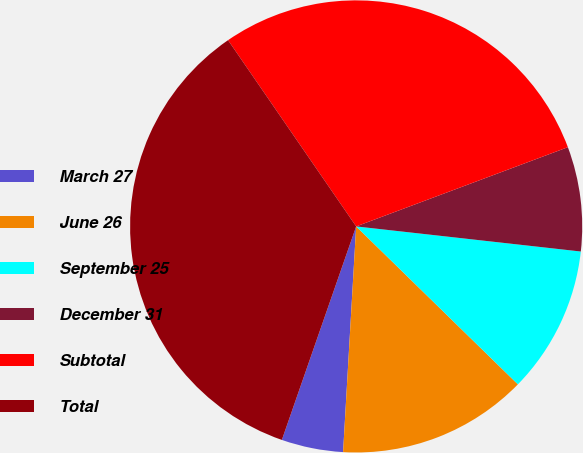Convert chart. <chart><loc_0><loc_0><loc_500><loc_500><pie_chart><fcel>March 27<fcel>June 26<fcel>September 25<fcel>December 31<fcel>Subtotal<fcel>Total<nl><fcel>4.41%<fcel>13.61%<fcel>10.54%<fcel>7.47%<fcel>28.89%<fcel>35.08%<nl></chart> 